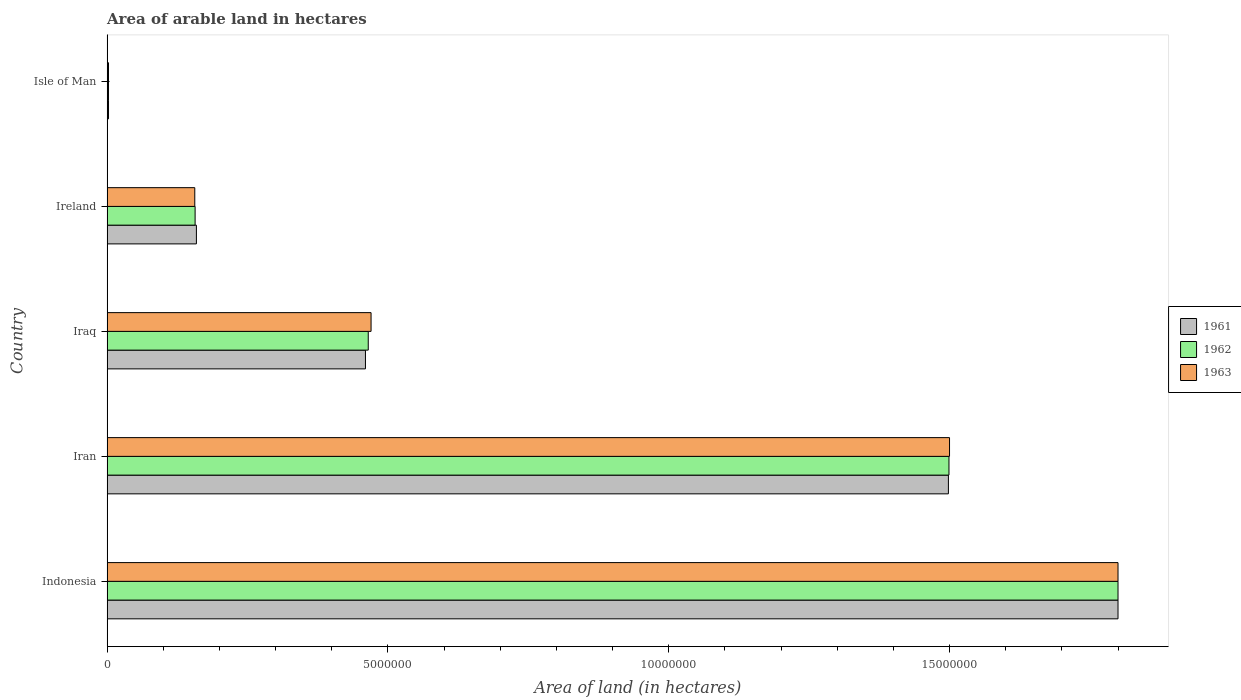How many groups of bars are there?
Provide a short and direct response. 5. Are the number of bars on each tick of the Y-axis equal?
Your answer should be very brief. Yes. How many bars are there on the 3rd tick from the bottom?
Your answer should be very brief. 3. What is the label of the 5th group of bars from the top?
Provide a short and direct response. Indonesia. In how many cases, is the number of bars for a given country not equal to the number of legend labels?
Provide a succinct answer. 0. What is the total arable land in 1963 in Iran?
Offer a terse response. 1.50e+07. Across all countries, what is the maximum total arable land in 1961?
Give a very brief answer. 1.80e+07. Across all countries, what is the minimum total arable land in 1961?
Keep it short and to the point. 2.50e+04. In which country was the total arable land in 1963 minimum?
Keep it short and to the point. Isle of Man. What is the total total arable land in 1963 in the graph?
Make the answer very short. 3.93e+07. What is the difference between the total arable land in 1963 in Iraq and that in Isle of Man?
Give a very brief answer. 4.68e+06. What is the difference between the total arable land in 1962 in Isle of Man and the total arable land in 1961 in Indonesia?
Provide a short and direct response. -1.80e+07. What is the average total arable land in 1961 per country?
Provide a succinct answer. 7.84e+06. What is the difference between the total arable land in 1963 and total arable land in 1962 in Ireland?
Make the answer very short. -6000. What is the ratio of the total arable land in 1962 in Indonesia to that in Iraq?
Make the answer very short. 3.87. Is the total arable land in 1963 in Indonesia less than that in Ireland?
Provide a short and direct response. No. Is the difference between the total arable land in 1963 in Iran and Isle of Man greater than the difference between the total arable land in 1962 in Iran and Isle of Man?
Provide a short and direct response. Yes. What is the difference between the highest and the second highest total arable land in 1961?
Offer a terse response. 3.02e+06. What is the difference between the highest and the lowest total arable land in 1961?
Provide a succinct answer. 1.80e+07. Is the sum of the total arable land in 1962 in Iran and Iraq greater than the maximum total arable land in 1961 across all countries?
Offer a very short reply. Yes. Are all the bars in the graph horizontal?
Ensure brevity in your answer.  Yes. What is the difference between two consecutive major ticks on the X-axis?
Your answer should be very brief. 5.00e+06. Are the values on the major ticks of X-axis written in scientific E-notation?
Offer a very short reply. No. Where does the legend appear in the graph?
Provide a short and direct response. Center right. What is the title of the graph?
Keep it short and to the point. Area of arable land in hectares. Does "1964" appear as one of the legend labels in the graph?
Give a very brief answer. No. What is the label or title of the X-axis?
Make the answer very short. Area of land (in hectares). What is the Area of land (in hectares) of 1961 in Indonesia?
Provide a short and direct response. 1.80e+07. What is the Area of land (in hectares) in 1962 in Indonesia?
Offer a very short reply. 1.80e+07. What is the Area of land (in hectares) in 1963 in Indonesia?
Provide a succinct answer. 1.80e+07. What is the Area of land (in hectares) of 1961 in Iran?
Your answer should be very brief. 1.50e+07. What is the Area of land (in hectares) in 1962 in Iran?
Offer a very short reply. 1.50e+07. What is the Area of land (in hectares) in 1963 in Iran?
Keep it short and to the point. 1.50e+07. What is the Area of land (in hectares) in 1961 in Iraq?
Offer a terse response. 4.60e+06. What is the Area of land (in hectares) in 1962 in Iraq?
Give a very brief answer. 4.65e+06. What is the Area of land (in hectares) in 1963 in Iraq?
Provide a succinct answer. 4.70e+06. What is the Area of land (in hectares) in 1961 in Ireland?
Give a very brief answer. 1.59e+06. What is the Area of land (in hectares) of 1962 in Ireland?
Ensure brevity in your answer.  1.57e+06. What is the Area of land (in hectares) of 1963 in Ireland?
Offer a very short reply. 1.56e+06. What is the Area of land (in hectares) in 1961 in Isle of Man?
Offer a very short reply. 2.50e+04. What is the Area of land (in hectares) in 1962 in Isle of Man?
Your response must be concise. 2.50e+04. What is the Area of land (in hectares) in 1963 in Isle of Man?
Keep it short and to the point. 2.47e+04. Across all countries, what is the maximum Area of land (in hectares) of 1961?
Your response must be concise. 1.80e+07. Across all countries, what is the maximum Area of land (in hectares) in 1962?
Offer a terse response. 1.80e+07. Across all countries, what is the maximum Area of land (in hectares) in 1963?
Offer a very short reply. 1.80e+07. Across all countries, what is the minimum Area of land (in hectares) in 1961?
Your response must be concise. 2.50e+04. Across all countries, what is the minimum Area of land (in hectares) of 1962?
Make the answer very short. 2.50e+04. Across all countries, what is the minimum Area of land (in hectares) in 1963?
Offer a very short reply. 2.47e+04. What is the total Area of land (in hectares) in 1961 in the graph?
Provide a short and direct response. 3.92e+07. What is the total Area of land (in hectares) in 1962 in the graph?
Provide a short and direct response. 3.92e+07. What is the total Area of land (in hectares) of 1963 in the graph?
Provide a short and direct response. 3.93e+07. What is the difference between the Area of land (in hectares) in 1961 in Indonesia and that in Iran?
Give a very brief answer. 3.02e+06. What is the difference between the Area of land (in hectares) of 1962 in Indonesia and that in Iran?
Ensure brevity in your answer.  3.01e+06. What is the difference between the Area of land (in hectares) of 1961 in Indonesia and that in Iraq?
Your answer should be very brief. 1.34e+07. What is the difference between the Area of land (in hectares) in 1962 in Indonesia and that in Iraq?
Keep it short and to the point. 1.34e+07. What is the difference between the Area of land (in hectares) of 1963 in Indonesia and that in Iraq?
Provide a short and direct response. 1.33e+07. What is the difference between the Area of land (in hectares) in 1961 in Indonesia and that in Ireland?
Your response must be concise. 1.64e+07. What is the difference between the Area of land (in hectares) of 1962 in Indonesia and that in Ireland?
Offer a very short reply. 1.64e+07. What is the difference between the Area of land (in hectares) in 1963 in Indonesia and that in Ireland?
Provide a succinct answer. 1.64e+07. What is the difference between the Area of land (in hectares) of 1961 in Indonesia and that in Isle of Man?
Ensure brevity in your answer.  1.80e+07. What is the difference between the Area of land (in hectares) in 1962 in Indonesia and that in Isle of Man?
Make the answer very short. 1.80e+07. What is the difference between the Area of land (in hectares) in 1963 in Indonesia and that in Isle of Man?
Offer a very short reply. 1.80e+07. What is the difference between the Area of land (in hectares) of 1961 in Iran and that in Iraq?
Make the answer very short. 1.04e+07. What is the difference between the Area of land (in hectares) in 1962 in Iran and that in Iraq?
Ensure brevity in your answer.  1.03e+07. What is the difference between the Area of land (in hectares) in 1963 in Iran and that in Iraq?
Ensure brevity in your answer.  1.03e+07. What is the difference between the Area of land (in hectares) of 1961 in Iran and that in Ireland?
Keep it short and to the point. 1.34e+07. What is the difference between the Area of land (in hectares) in 1962 in Iran and that in Ireland?
Make the answer very short. 1.34e+07. What is the difference between the Area of land (in hectares) of 1963 in Iran and that in Ireland?
Your answer should be compact. 1.34e+07. What is the difference between the Area of land (in hectares) in 1961 in Iran and that in Isle of Man?
Provide a short and direct response. 1.50e+07. What is the difference between the Area of land (in hectares) in 1962 in Iran and that in Isle of Man?
Your answer should be very brief. 1.50e+07. What is the difference between the Area of land (in hectares) of 1963 in Iran and that in Isle of Man?
Offer a terse response. 1.50e+07. What is the difference between the Area of land (in hectares) of 1961 in Iraq and that in Ireland?
Make the answer very short. 3.01e+06. What is the difference between the Area of land (in hectares) in 1962 in Iraq and that in Ireland?
Your answer should be very brief. 3.08e+06. What is the difference between the Area of land (in hectares) in 1963 in Iraq and that in Ireland?
Make the answer very short. 3.14e+06. What is the difference between the Area of land (in hectares) in 1961 in Iraq and that in Isle of Man?
Make the answer very short. 4.58e+06. What is the difference between the Area of land (in hectares) of 1962 in Iraq and that in Isle of Man?
Offer a very short reply. 4.62e+06. What is the difference between the Area of land (in hectares) in 1963 in Iraq and that in Isle of Man?
Your answer should be compact. 4.68e+06. What is the difference between the Area of land (in hectares) of 1961 in Ireland and that in Isle of Man?
Your answer should be compact. 1.56e+06. What is the difference between the Area of land (in hectares) in 1962 in Ireland and that in Isle of Man?
Your answer should be compact. 1.54e+06. What is the difference between the Area of land (in hectares) in 1963 in Ireland and that in Isle of Man?
Your response must be concise. 1.54e+06. What is the difference between the Area of land (in hectares) of 1961 in Indonesia and the Area of land (in hectares) of 1962 in Iran?
Your answer should be very brief. 3.01e+06. What is the difference between the Area of land (in hectares) in 1961 in Indonesia and the Area of land (in hectares) in 1962 in Iraq?
Your response must be concise. 1.34e+07. What is the difference between the Area of land (in hectares) of 1961 in Indonesia and the Area of land (in hectares) of 1963 in Iraq?
Offer a terse response. 1.33e+07. What is the difference between the Area of land (in hectares) in 1962 in Indonesia and the Area of land (in hectares) in 1963 in Iraq?
Provide a succinct answer. 1.33e+07. What is the difference between the Area of land (in hectares) in 1961 in Indonesia and the Area of land (in hectares) in 1962 in Ireland?
Ensure brevity in your answer.  1.64e+07. What is the difference between the Area of land (in hectares) in 1961 in Indonesia and the Area of land (in hectares) in 1963 in Ireland?
Your answer should be very brief. 1.64e+07. What is the difference between the Area of land (in hectares) in 1962 in Indonesia and the Area of land (in hectares) in 1963 in Ireland?
Ensure brevity in your answer.  1.64e+07. What is the difference between the Area of land (in hectares) in 1961 in Indonesia and the Area of land (in hectares) in 1962 in Isle of Man?
Keep it short and to the point. 1.80e+07. What is the difference between the Area of land (in hectares) in 1961 in Indonesia and the Area of land (in hectares) in 1963 in Isle of Man?
Your answer should be very brief. 1.80e+07. What is the difference between the Area of land (in hectares) in 1962 in Indonesia and the Area of land (in hectares) in 1963 in Isle of Man?
Keep it short and to the point. 1.80e+07. What is the difference between the Area of land (in hectares) in 1961 in Iran and the Area of land (in hectares) in 1962 in Iraq?
Provide a short and direct response. 1.03e+07. What is the difference between the Area of land (in hectares) of 1961 in Iran and the Area of land (in hectares) of 1963 in Iraq?
Ensure brevity in your answer.  1.03e+07. What is the difference between the Area of land (in hectares) of 1962 in Iran and the Area of land (in hectares) of 1963 in Iraq?
Provide a short and direct response. 1.03e+07. What is the difference between the Area of land (in hectares) in 1961 in Iran and the Area of land (in hectares) in 1962 in Ireland?
Ensure brevity in your answer.  1.34e+07. What is the difference between the Area of land (in hectares) of 1961 in Iran and the Area of land (in hectares) of 1963 in Ireland?
Your response must be concise. 1.34e+07. What is the difference between the Area of land (in hectares) in 1962 in Iran and the Area of land (in hectares) in 1963 in Ireland?
Provide a short and direct response. 1.34e+07. What is the difference between the Area of land (in hectares) of 1961 in Iran and the Area of land (in hectares) of 1962 in Isle of Man?
Provide a short and direct response. 1.50e+07. What is the difference between the Area of land (in hectares) in 1961 in Iran and the Area of land (in hectares) in 1963 in Isle of Man?
Ensure brevity in your answer.  1.50e+07. What is the difference between the Area of land (in hectares) of 1962 in Iran and the Area of land (in hectares) of 1963 in Isle of Man?
Provide a short and direct response. 1.50e+07. What is the difference between the Area of land (in hectares) of 1961 in Iraq and the Area of land (in hectares) of 1962 in Ireland?
Provide a short and direct response. 3.03e+06. What is the difference between the Area of land (in hectares) of 1961 in Iraq and the Area of land (in hectares) of 1963 in Ireland?
Provide a succinct answer. 3.04e+06. What is the difference between the Area of land (in hectares) in 1962 in Iraq and the Area of land (in hectares) in 1963 in Ireland?
Your answer should be compact. 3.09e+06. What is the difference between the Area of land (in hectares) in 1961 in Iraq and the Area of land (in hectares) in 1962 in Isle of Man?
Your answer should be compact. 4.58e+06. What is the difference between the Area of land (in hectares) of 1961 in Iraq and the Area of land (in hectares) of 1963 in Isle of Man?
Keep it short and to the point. 4.58e+06. What is the difference between the Area of land (in hectares) of 1962 in Iraq and the Area of land (in hectares) of 1963 in Isle of Man?
Keep it short and to the point. 4.63e+06. What is the difference between the Area of land (in hectares) of 1961 in Ireland and the Area of land (in hectares) of 1962 in Isle of Man?
Your answer should be compact. 1.56e+06. What is the difference between the Area of land (in hectares) of 1961 in Ireland and the Area of land (in hectares) of 1963 in Isle of Man?
Provide a short and direct response. 1.57e+06. What is the difference between the Area of land (in hectares) of 1962 in Ireland and the Area of land (in hectares) of 1963 in Isle of Man?
Offer a terse response. 1.54e+06. What is the average Area of land (in hectares) in 1961 per country?
Keep it short and to the point. 7.84e+06. What is the average Area of land (in hectares) of 1962 per country?
Provide a short and direct response. 7.85e+06. What is the average Area of land (in hectares) in 1963 per country?
Make the answer very short. 7.86e+06. What is the difference between the Area of land (in hectares) of 1961 and Area of land (in hectares) of 1963 in Indonesia?
Keep it short and to the point. 0. What is the difference between the Area of land (in hectares) of 1961 and Area of land (in hectares) of 1962 in Iran?
Keep it short and to the point. -10000. What is the difference between the Area of land (in hectares) in 1961 and Area of land (in hectares) in 1963 in Iran?
Give a very brief answer. -2.00e+04. What is the difference between the Area of land (in hectares) of 1961 and Area of land (in hectares) of 1963 in Iraq?
Offer a very short reply. -1.00e+05. What is the difference between the Area of land (in hectares) of 1962 and Area of land (in hectares) of 1963 in Iraq?
Provide a succinct answer. -5.00e+04. What is the difference between the Area of land (in hectares) in 1961 and Area of land (in hectares) in 1962 in Ireland?
Offer a terse response. 2.30e+04. What is the difference between the Area of land (in hectares) of 1961 and Area of land (in hectares) of 1963 in Ireland?
Ensure brevity in your answer.  2.90e+04. What is the difference between the Area of land (in hectares) in 1962 and Area of land (in hectares) in 1963 in Ireland?
Offer a terse response. 6000. What is the difference between the Area of land (in hectares) of 1961 and Area of land (in hectares) of 1962 in Isle of Man?
Your answer should be very brief. 0. What is the difference between the Area of land (in hectares) of 1961 and Area of land (in hectares) of 1963 in Isle of Man?
Provide a short and direct response. 300. What is the difference between the Area of land (in hectares) of 1962 and Area of land (in hectares) of 1963 in Isle of Man?
Offer a very short reply. 300. What is the ratio of the Area of land (in hectares) in 1961 in Indonesia to that in Iran?
Your answer should be compact. 1.2. What is the ratio of the Area of land (in hectares) of 1962 in Indonesia to that in Iran?
Ensure brevity in your answer.  1.2. What is the ratio of the Area of land (in hectares) of 1961 in Indonesia to that in Iraq?
Your answer should be compact. 3.91. What is the ratio of the Area of land (in hectares) in 1962 in Indonesia to that in Iraq?
Make the answer very short. 3.87. What is the ratio of the Area of land (in hectares) in 1963 in Indonesia to that in Iraq?
Your answer should be compact. 3.83. What is the ratio of the Area of land (in hectares) in 1961 in Indonesia to that in Ireland?
Keep it short and to the point. 11.32. What is the ratio of the Area of land (in hectares) of 1962 in Indonesia to that in Ireland?
Give a very brief answer. 11.49. What is the ratio of the Area of land (in hectares) in 1963 in Indonesia to that in Ireland?
Your response must be concise. 11.53. What is the ratio of the Area of land (in hectares) of 1961 in Indonesia to that in Isle of Man?
Offer a terse response. 720. What is the ratio of the Area of land (in hectares) in 1962 in Indonesia to that in Isle of Man?
Your answer should be very brief. 720. What is the ratio of the Area of land (in hectares) in 1963 in Indonesia to that in Isle of Man?
Your answer should be very brief. 728.74. What is the ratio of the Area of land (in hectares) of 1961 in Iran to that in Iraq?
Your answer should be very brief. 3.26. What is the ratio of the Area of land (in hectares) of 1962 in Iran to that in Iraq?
Keep it short and to the point. 3.22. What is the ratio of the Area of land (in hectares) of 1963 in Iran to that in Iraq?
Your response must be concise. 3.19. What is the ratio of the Area of land (in hectares) in 1961 in Iran to that in Ireland?
Give a very brief answer. 9.42. What is the ratio of the Area of land (in hectares) in 1962 in Iran to that in Ireland?
Your answer should be very brief. 9.57. What is the ratio of the Area of land (in hectares) in 1963 in Iran to that in Ireland?
Make the answer very short. 9.61. What is the ratio of the Area of land (in hectares) in 1961 in Iran to that in Isle of Man?
Your answer should be very brief. 599.2. What is the ratio of the Area of land (in hectares) in 1962 in Iran to that in Isle of Man?
Your answer should be very brief. 599.6. What is the ratio of the Area of land (in hectares) in 1963 in Iran to that in Isle of Man?
Make the answer very short. 607.29. What is the ratio of the Area of land (in hectares) in 1961 in Iraq to that in Ireland?
Offer a terse response. 2.89. What is the ratio of the Area of land (in hectares) in 1962 in Iraq to that in Ireland?
Offer a terse response. 2.97. What is the ratio of the Area of land (in hectares) of 1963 in Iraq to that in Ireland?
Ensure brevity in your answer.  3.01. What is the ratio of the Area of land (in hectares) in 1961 in Iraq to that in Isle of Man?
Keep it short and to the point. 184. What is the ratio of the Area of land (in hectares) in 1962 in Iraq to that in Isle of Man?
Make the answer very short. 186. What is the ratio of the Area of land (in hectares) in 1963 in Iraq to that in Isle of Man?
Your response must be concise. 190.28. What is the ratio of the Area of land (in hectares) of 1961 in Ireland to that in Isle of Man?
Give a very brief answer. 63.6. What is the ratio of the Area of land (in hectares) of 1962 in Ireland to that in Isle of Man?
Provide a succinct answer. 62.68. What is the ratio of the Area of land (in hectares) in 1963 in Ireland to that in Isle of Man?
Provide a short and direct response. 63.2. What is the difference between the highest and the second highest Area of land (in hectares) in 1961?
Your answer should be very brief. 3.02e+06. What is the difference between the highest and the second highest Area of land (in hectares) in 1962?
Provide a short and direct response. 3.01e+06. What is the difference between the highest and the second highest Area of land (in hectares) of 1963?
Make the answer very short. 3.00e+06. What is the difference between the highest and the lowest Area of land (in hectares) of 1961?
Give a very brief answer. 1.80e+07. What is the difference between the highest and the lowest Area of land (in hectares) of 1962?
Offer a terse response. 1.80e+07. What is the difference between the highest and the lowest Area of land (in hectares) in 1963?
Your response must be concise. 1.80e+07. 